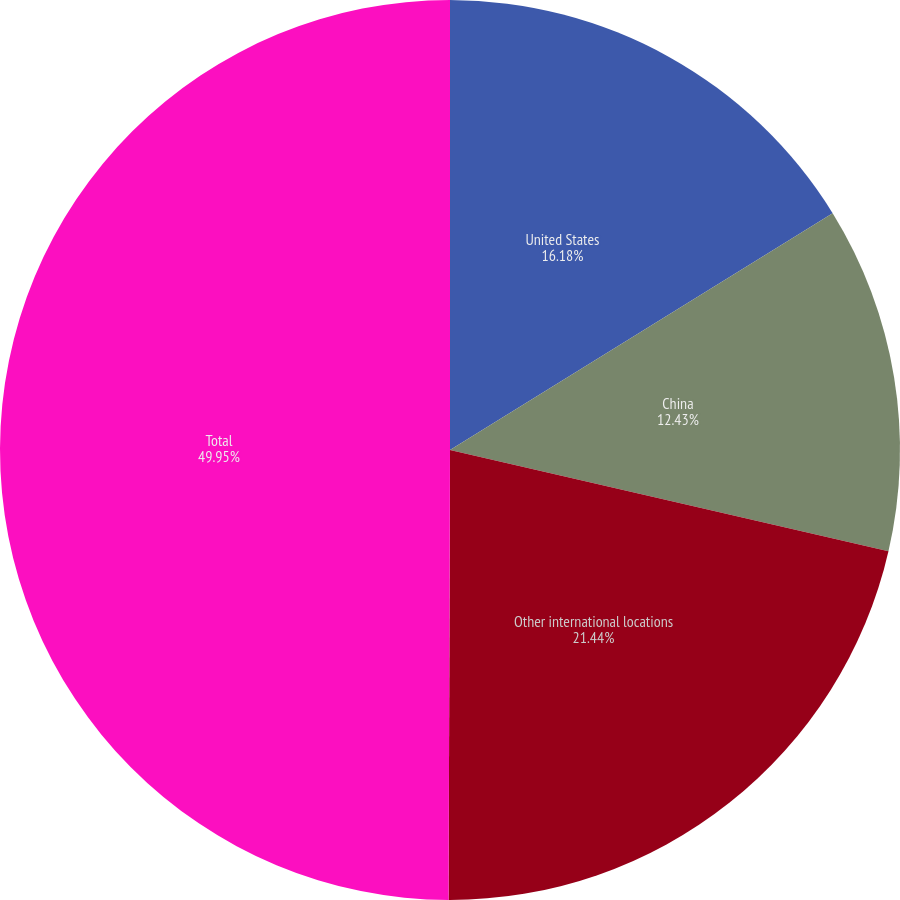Convert chart to OTSL. <chart><loc_0><loc_0><loc_500><loc_500><pie_chart><fcel>United States<fcel>China<fcel>Other international locations<fcel>Total<nl><fcel>16.18%<fcel>12.43%<fcel>21.44%<fcel>49.95%<nl></chart> 